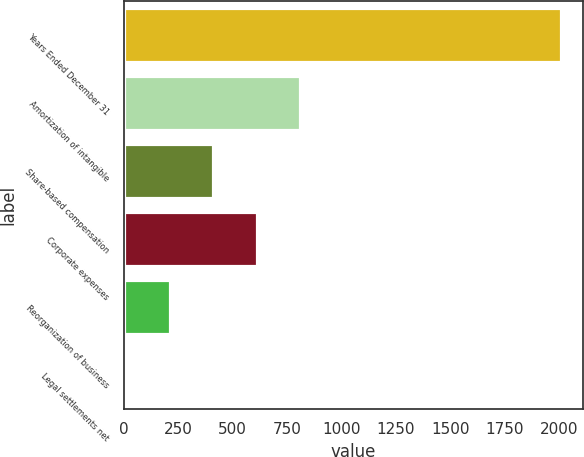<chart> <loc_0><loc_0><loc_500><loc_500><bar_chart><fcel>Years Ended December 31<fcel>Amortization of intangible<fcel>Share-based compensation<fcel>Corporate expenses<fcel>Reorganization of business<fcel>Legal settlements net<nl><fcel>2008<fcel>811.6<fcel>412.8<fcel>612.2<fcel>213.4<fcel>14<nl></chart> 